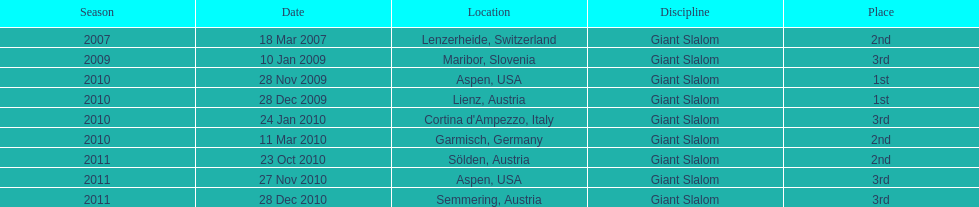Where did her first successful outcome take place? Aspen, USA. 